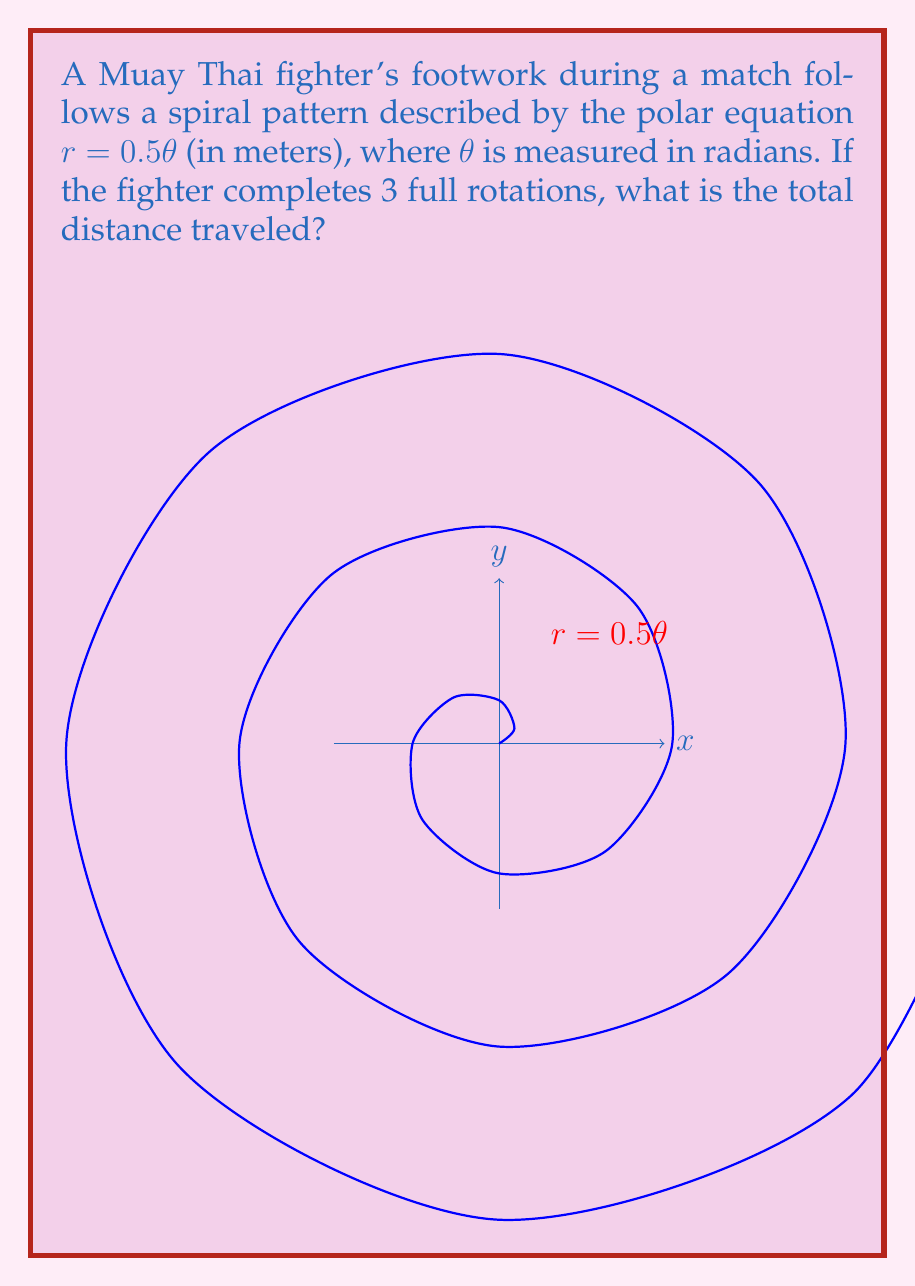Could you help me with this problem? Let's approach this step-by-step:

1) The spiral is given by $r = 0.5\theta$, where $r$ is in meters and $\theta$ is in radians.

2) For 3 full rotations, $\theta$ goes from 0 to $6\pi$ radians.

3) To find the arc length of a polar curve, we use the formula:

   $$L = \int_a^b \sqrt{r^2 + \left(\frac{dr}{d\theta}\right)^2} d\theta$$

4) Here, $r = 0.5\theta$ and $\frac{dr}{d\theta} = 0.5$

5) Substituting into the formula:

   $$L = \int_0^{6\pi} \sqrt{(0.5\theta)^2 + (0.5)^2} d\theta$$

6) Simplify under the square root:

   $$L = \int_0^{6\pi} \sqrt{0.25\theta^2 + 0.25} d\theta = 0.5 \int_0^{6\pi} \sqrt{\theta^2 + 1} d\theta$$

7) This integral can be solved using the substitution $\theta = \sinh u$:

   $$L = 0.5 [\theta\sqrt{\theta^2+1} + \ln(\theta + \sqrt{\theta^2+1})]_0^{6\pi}$$

8) Evaluating at the limits:

   $$L = 0.5 [6\pi\sqrt{36\pi^2+1} + \ln(6\pi + \sqrt{36\pi^2+1}) - 0]$$

9) Calculating this numerically (as it's not easily simplified further):

   $$L \approx 56.55 \text{ meters}$$
Answer: $56.55$ meters 